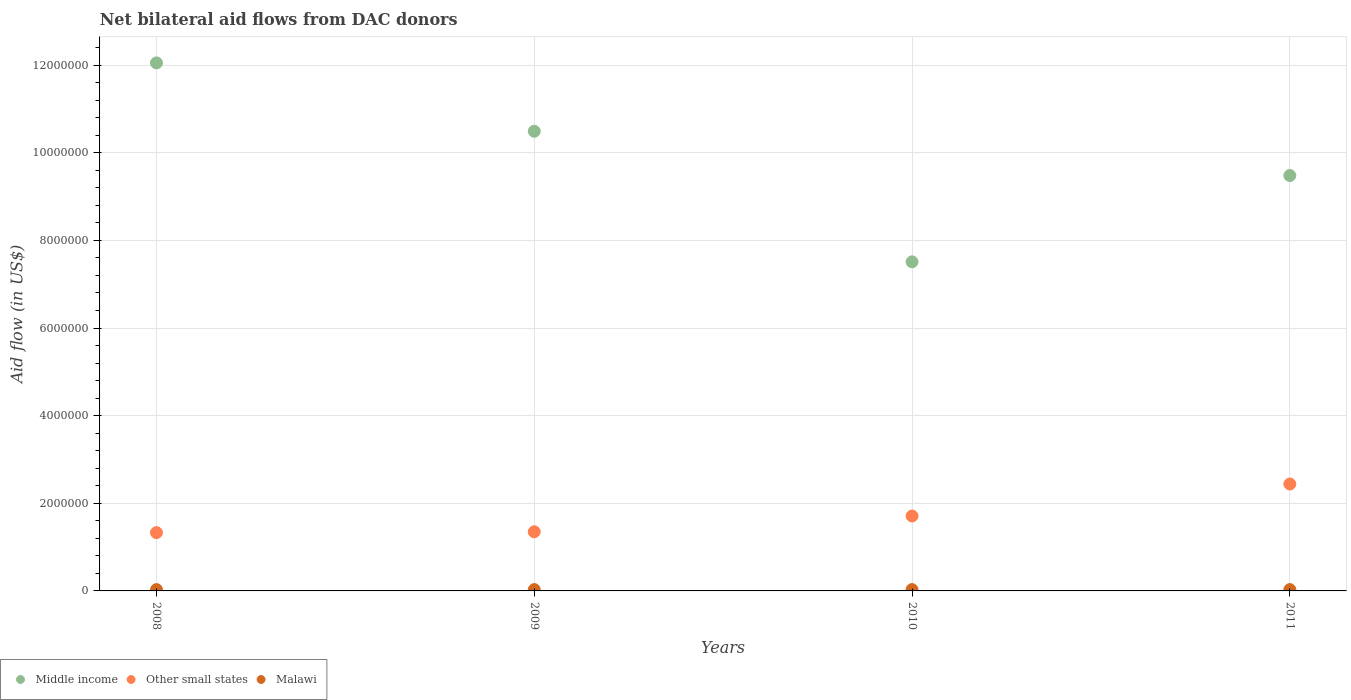What is the net bilateral aid flow in Malawi in 2008?
Keep it short and to the point. 3.00e+04. Across all years, what is the maximum net bilateral aid flow in Other small states?
Your answer should be very brief. 2.44e+06. What is the total net bilateral aid flow in Middle income in the graph?
Provide a succinct answer. 3.95e+07. What is the difference between the net bilateral aid flow in Middle income in 2011 and the net bilateral aid flow in Malawi in 2008?
Give a very brief answer. 9.45e+06. In the year 2009, what is the difference between the net bilateral aid flow in Other small states and net bilateral aid flow in Malawi?
Provide a short and direct response. 1.32e+06. What is the ratio of the net bilateral aid flow in Other small states in 2009 to that in 2010?
Your response must be concise. 0.79. What is the difference between the highest and the second highest net bilateral aid flow in Malawi?
Offer a very short reply. 0. In how many years, is the net bilateral aid flow in Middle income greater than the average net bilateral aid flow in Middle income taken over all years?
Offer a terse response. 2. Is the sum of the net bilateral aid flow in Malawi in 2008 and 2011 greater than the maximum net bilateral aid flow in Other small states across all years?
Ensure brevity in your answer.  No. Is the net bilateral aid flow in Malawi strictly greater than the net bilateral aid flow in Other small states over the years?
Keep it short and to the point. No. Is the net bilateral aid flow in Other small states strictly less than the net bilateral aid flow in Malawi over the years?
Keep it short and to the point. No. How many years are there in the graph?
Ensure brevity in your answer.  4. Are the values on the major ticks of Y-axis written in scientific E-notation?
Ensure brevity in your answer.  No. Where does the legend appear in the graph?
Offer a very short reply. Bottom left. How many legend labels are there?
Provide a short and direct response. 3. What is the title of the graph?
Give a very brief answer. Net bilateral aid flows from DAC donors. What is the label or title of the Y-axis?
Give a very brief answer. Aid flow (in US$). What is the Aid flow (in US$) in Middle income in 2008?
Provide a short and direct response. 1.20e+07. What is the Aid flow (in US$) in Other small states in 2008?
Your response must be concise. 1.33e+06. What is the Aid flow (in US$) of Malawi in 2008?
Ensure brevity in your answer.  3.00e+04. What is the Aid flow (in US$) of Middle income in 2009?
Make the answer very short. 1.05e+07. What is the Aid flow (in US$) of Other small states in 2009?
Offer a terse response. 1.35e+06. What is the Aid flow (in US$) of Malawi in 2009?
Provide a succinct answer. 3.00e+04. What is the Aid flow (in US$) in Middle income in 2010?
Your answer should be compact. 7.51e+06. What is the Aid flow (in US$) of Other small states in 2010?
Offer a terse response. 1.71e+06. What is the Aid flow (in US$) of Middle income in 2011?
Provide a succinct answer. 9.48e+06. What is the Aid flow (in US$) in Other small states in 2011?
Your answer should be compact. 2.44e+06. What is the Aid flow (in US$) in Malawi in 2011?
Your answer should be compact. 3.00e+04. Across all years, what is the maximum Aid flow (in US$) in Middle income?
Ensure brevity in your answer.  1.20e+07. Across all years, what is the maximum Aid flow (in US$) of Other small states?
Provide a succinct answer. 2.44e+06. Across all years, what is the maximum Aid flow (in US$) in Malawi?
Offer a terse response. 3.00e+04. Across all years, what is the minimum Aid flow (in US$) of Middle income?
Your answer should be compact. 7.51e+06. Across all years, what is the minimum Aid flow (in US$) of Other small states?
Your answer should be very brief. 1.33e+06. What is the total Aid flow (in US$) of Middle income in the graph?
Your answer should be compact. 3.95e+07. What is the total Aid flow (in US$) in Other small states in the graph?
Your response must be concise. 6.83e+06. What is the total Aid flow (in US$) in Malawi in the graph?
Offer a very short reply. 1.20e+05. What is the difference between the Aid flow (in US$) in Middle income in 2008 and that in 2009?
Give a very brief answer. 1.56e+06. What is the difference between the Aid flow (in US$) of Malawi in 2008 and that in 2009?
Offer a very short reply. 0. What is the difference between the Aid flow (in US$) in Middle income in 2008 and that in 2010?
Give a very brief answer. 4.54e+06. What is the difference between the Aid flow (in US$) of Other small states in 2008 and that in 2010?
Keep it short and to the point. -3.80e+05. What is the difference between the Aid flow (in US$) of Middle income in 2008 and that in 2011?
Give a very brief answer. 2.57e+06. What is the difference between the Aid flow (in US$) in Other small states in 2008 and that in 2011?
Offer a very short reply. -1.11e+06. What is the difference between the Aid flow (in US$) in Malawi in 2008 and that in 2011?
Make the answer very short. 0. What is the difference between the Aid flow (in US$) in Middle income in 2009 and that in 2010?
Offer a very short reply. 2.98e+06. What is the difference between the Aid flow (in US$) in Other small states in 2009 and that in 2010?
Provide a succinct answer. -3.60e+05. What is the difference between the Aid flow (in US$) in Malawi in 2009 and that in 2010?
Provide a short and direct response. 0. What is the difference between the Aid flow (in US$) of Middle income in 2009 and that in 2011?
Provide a short and direct response. 1.01e+06. What is the difference between the Aid flow (in US$) of Other small states in 2009 and that in 2011?
Keep it short and to the point. -1.09e+06. What is the difference between the Aid flow (in US$) of Malawi in 2009 and that in 2011?
Keep it short and to the point. 0. What is the difference between the Aid flow (in US$) of Middle income in 2010 and that in 2011?
Make the answer very short. -1.97e+06. What is the difference between the Aid flow (in US$) in Other small states in 2010 and that in 2011?
Give a very brief answer. -7.30e+05. What is the difference between the Aid flow (in US$) in Middle income in 2008 and the Aid flow (in US$) in Other small states in 2009?
Your answer should be very brief. 1.07e+07. What is the difference between the Aid flow (in US$) of Middle income in 2008 and the Aid flow (in US$) of Malawi in 2009?
Keep it short and to the point. 1.20e+07. What is the difference between the Aid flow (in US$) of Other small states in 2008 and the Aid flow (in US$) of Malawi in 2009?
Your answer should be compact. 1.30e+06. What is the difference between the Aid flow (in US$) in Middle income in 2008 and the Aid flow (in US$) in Other small states in 2010?
Your answer should be compact. 1.03e+07. What is the difference between the Aid flow (in US$) of Middle income in 2008 and the Aid flow (in US$) of Malawi in 2010?
Offer a terse response. 1.20e+07. What is the difference between the Aid flow (in US$) in Other small states in 2008 and the Aid flow (in US$) in Malawi in 2010?
Your answer should be compact. 1.30e+06. What is the difference between the Aid flow (in US$) of Middle income in 2008 and the Aid flow (in US$) of Other small states in 2011?
Provide a succinct answer. 9.61e+06. What is the difference between the Aid flow (in US$) in Middle income in 2008 and the Aid flow (in US$) in Malawi in 2011?
Keep it short and to the point. 1.20e+07. What is the difference between the Aid flow (in US$) of Other small states in 2008 and the Aid flow (in US$) of Malawi in 2011?
Provide a succinct answer. 1.30e+06. What is the difference between the Aid flow (in US$) in Middle income in 2009 and the Aid flow (in US$) in Other small states in 2010?
Keep it short and to the point. 8.78e+06. What is the difference between the Aid flow (in US$) in Middle income in 2009 and the Aid flow (in US$) in Malawi in 2010?
Offer a very short reply. 1.05e+07. What is the difference between the Aid flow (in US$) in Other small states in 2009 and the Aid flow (in US$) in Malawi in 2010?
Offer a very short reply. 1.32e+06. What is the difference between the Aid flow (in US$) in Middle income in 2009 and the Aid flow (in US$) in Other small states in 2011?
Your response must be concise. 8.05e+06. What is the difference between the Aid flow (in US$) in Middle income in 2009 and the Aid flow (in US$) in Malawi in 2011?
Your answer should be compact. 1.05e+07. What is the difference between the Aid flow (in US$) in Other small states in 2009 and the Aid flow (in US$) in Malawi in 2011?
Give a very brief answer. 1.32e+06. What is the difference between the Aid flow (in US$) of Middle income in 2010 and the Aid flow (in US$) of Other small states in 2011?
Provide a succinct answer. 5.07e+06. What is the difference between the Aid flow (in US$) in Middle income in 2010 and the Aid flow (in US$) in Malawi in 2011?
Give a very brief answer. 7.48e+06. What is the difference between the Aid flow (in US$) of Other small states in 2010 and the Aid flow (in US$) of Malawi in 2011?
Offer a very short reply. 1.68e+06. What is the average Aid flow (in US$) in Middle income per year?
Keep it short and to the point. 9.88e+06. What is the average Aid flow (in US$) of Other small states per year?
Offer a very short reply. 1.71e+06. In the year 2008, what is the difference between the Aid flow (in US$) in Middle income and Aid flow (in US$) in Other small states?
Your answer should be compact. 1.07e+07. In the year 2008, what is the difference between the Aid flow (in US$) of Middle income and Aid flow (in US$) of Malawi?
Ensure brevity in your answer.  1.20e+07. In the year 2008, what is the difference between the Aid flow (in US$) in Other small states and Aid flow (in US$) in Malawi?
Keep it short and to the point. 1.30e+06. In the year 2009, what is the difference between the Aid flow (in US$) in Middle income and Aid flow (in US$) in Other small states?
Provide a short and direct response. 9.14e+06. In the year 2009, what is the difference between the Aid flow (in US$) of Middle income and Aid flow (in US$) of Malawi?
Give a very brief answer. 1.05e+07. In the year 2009, what is the difference between the Aid flow (in US$) of Other small states and Aid flow (in US$) of Malawi?
Ensure brevity in your answer.  1.32e+06. In the year 2010, what is the difference between the Aid flow (in US$) in Middle income and Aid flow (in US$) in Other small states?
Make the answer very short. 5.80e+06. In the year 2010, what is the difference between the Aid flow (in US$) in Middle income and Aid flow (in US$) in Malawi?
Your response must be concise. 7.48e+06. In the year 2010, what is the difference between the Aid flow (in US$) in Other small states and Aid flow (in US$) in Malawi?
Provide a succinct answer. 1.68e+06. In the year 2011, what is the difference between the Aid flow (in US$) of Middle income and Aid flow (in US$) of Other small states?
Offer a terse response. 7.04e+06. In the year 2011, what is the difference between the Aid flow (in US$) in Middle income and Aid flow (in US$) in Malawi?
Give a very brief answer. 9.45e+06. In the year 2011, what is the difference between the Aid flow (in US$) of Other small states and Aid flow (in US$) of Malawi?
Offer a very short reply. 2.41e+06. What is the ratio of the Aid flow (in US$) of Middle income in 2008 to that in 2009?
Make the answer very short. 1.15. What is the ratio of the Aid flow (in US$) of Other small states in 2008 to that in 2009?
Your response must be concise. 0.99. What is the ratio of the Aid flow (in US$) of Malawi in 2008 to that in 2009?
Keep it short and to the point. 1. What is the ratio of the Aid flow (in US$) of Middle income in 2008 to that in 2010?
Ensure brevity in your answer.  1.6. What is the ratio of the Aid flow (in US$) in Middle income in 2008 to that in 2011?
Keep it short and to the point. 1.27. What is the ratio of the Aid flow (in US$) in Other small states in 2008 to that in 2011?
Give a very brief answer. 0.55. What is the ratio of the Aid flow (in US$) of Malawi in 2008 to that in 2011?
Give a very brief answer. 1. What is the ratio of the Aid flow (in US$) in Middle income in 2009 to that in 2010?
Provide a succinct answer. 1.4. What is the ratio of the Aid flow (in US$) of Other small states in 2009 to that in 2010?
Offer a very short reply. 0.79. What is the ratio of the Aid flow (in US$) of Middle income in 2009 to that in 2011?
Make the answer very short. 1.11. What is the ratio of the Aid flow (in US$) in Other small states in 2009 to that in 2011?
Provide a short and direct response. 0.55. What is the ratio of the Aid flow (in US$) in Malawi in 2009 to that in 2011?
Your answer should be compact. 1. What is the ratio of the Aid flow (in US$) of Middle income in 2010 to that in 2011?
Make the answer very short. 0.79. What is the ratio of the Aid flow (in US$) in Other small states in 2010 to that in 2011?
Offer a very short reply. 0.7. What is the ratio of the Aid flow (in US$) of Malawi in 2010 to that in 2011?
Your answer should be compact. 1. What is the difference between the highest and the second highest Aid flow (in US$) in Middle income?
Provide a short and direct response. 1.56e+06. What is the difference between the highest and the second highest Aid flow (in US$) in Other small states?
Your answer should be very brief. 7.30e+05. What is the difference between the highest and the lowest Aid flow (in US$) in Middle income?
Ensure brevity in your answer.  4.54e+06. What is the difference between the highest and the lowest Aid flow (in US$) of Other small states?
Keep it short and to the point. 1.11e+06. What is the difference between the highest and the lowest Aid flow (in US$) in Malawi?
Offer a very short reply. 0. 